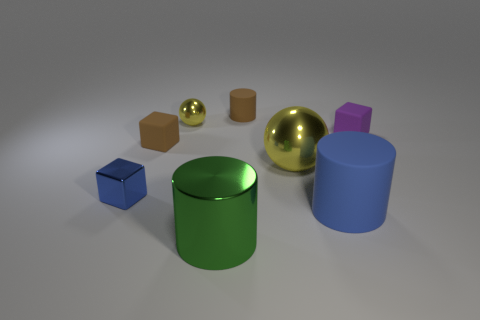Does the cube on the right side of the blue rubber cylinder have the same material as the large sphere?
Your response must be concise. No. Are there more rubber cubes that are left of the purple cube than blue shiny blocks on the right side of the large yellow metallic object?
Your answer should be compact. Yes. Is the color of the matte block on the left side of the large blue thing the same as the tiny cylinder?
Your answer should be compact. Yes. Are there any other things that have the same color as the large shiny cylinder?
Provide a succinct answer. No. Is the number of tiny objects in front of the tiny rubber cylinder greater than the number of tiny purple rubber objects?
Make the answer very short. Yes. Is the size of the green shiny object the same as the brown cylinder?
Give a very brief answer. No. What material is the big object that is the same shape as the small yellow thing?
Your answer should be compact. Metal. Are there any other things that are the same material as the small brown block?
Offer a terse response. Yes. What number of gray objects are small rubber cylinders or big rubber objects?
Your response must be concise. 0. What material is the cylinder that is right of the small cylinder?
Keep it short and to the point. Rubber. 